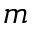<formula> <loc_0><loc_0><loc_500><loc_500>m</formula> 